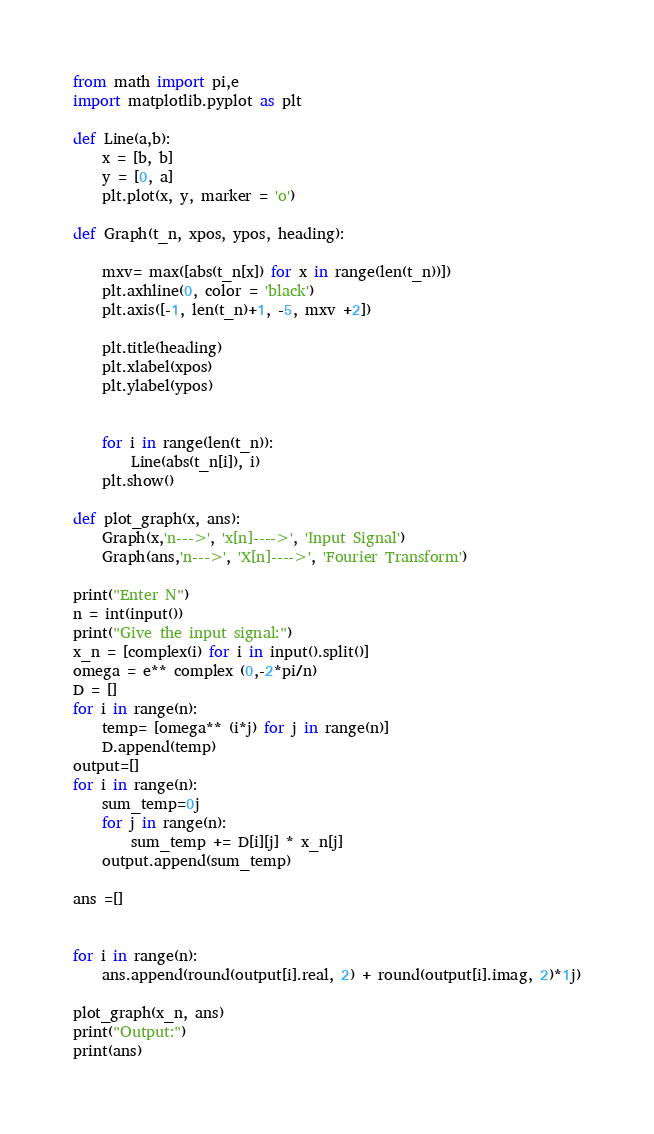<code> <loc_0><loc_0><loc_500><loc_500><_Python_>from math import pi,e
import matplotlib.pyplot as plt

def Line(a,b):
	x = [b, b]
	y = [0, a]
	plt.plot(x, y, marker = 'o')

def Graph(t_n, xpos, ypos, heading):

	mxv= max([abs(t_n[x]) for x in range(len(t_n))])
	plt.axhline(0, color = 'black')
	plt.axis([-1, len(t_n)+1, -5, mxv +2])

	plt.title(heading)
	plt.xlabel(xpos)
	plt.ylabel(ypos)


	for i in range(len(t_n)):
		Line(abs(t_n[i]), i)
	plt.show()

def plot_graph(x, ans):
	Graph(x,'n--->', 'x[n]---->', 'Input Signal')
	Graph(ans,'n--->', 'X[n]---->', 'Fourier Transform')

print("Enter N")
n = int(input())
print("Give the input signal:")
x_n = [complex(i) for i in input().split()]
omega = e** complex (0,-2*pi/n)
D = []
for i in range(n):
	temp= [omega** (i*j) for j in range(n)]
	D.append(temp)
output=[]
for i in range(n):
	sum_temp=0j
	for j in range(n):
		sum_temp += D[i][j] * x_n[j]
	output.append(sum_temp)

ans =[]


for i in range(n):
	ans.append(round(output[i].real, 2) + round(output[i].imag, 2)*1j)

plot_graph(x_n, ans)
print("Output:")
print(ans)

</code> 